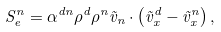Convert formula to latex. <formula><loc_0><loc_0><loc_500><loc_500>S _ { e } ^ { n } = \alpha ^ { d n } \rho ^ { d } \rho ^ { n } \vec { v } _ { n } \cdot \left ( \vec { v } _ { x } ^ { d } - \vec { v } _ { x } ^ { n } \right ) ,</formula> 